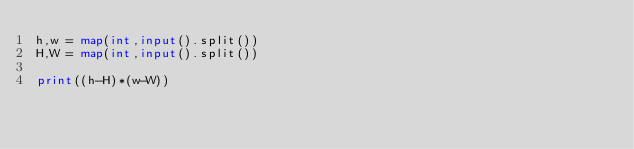Convert code to text. <code><loc_0><loc_0><loc_500><loc_500><_Python_>h,w = map(int,input().split())
H,W = map(int,input().split())

print((h-H)*(w-W))</code> 